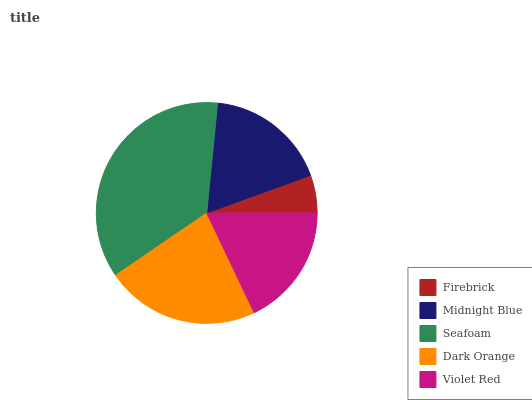Is Firebrick the minimum?
Answer yes or no. Yes. Is Seafoam the maximum?
Answer yes or no. Yes. Is Midnight Blue the minimum?
Answer yes or no. No. Is Midnight Blue the maximum?
Answer yes or no. No. Is Midnight Blue greater than Firebrick?
Answer yes or no. Yes. Is Firebrick less than Midnight Blue?
Answer yes or no. Yes. Is Firebrick greater than Midnight Blue?
Answer yes or no. No. Is Midnight Blue less than Firebrick?
Answer yes or no. No. Is Violet Red the high median?
Answer yes or no. Yes. Is Violet Red the low median?
Answer yes or no. Yes. Is Firebrick the high median?
Answer yes or no. No. Is Midnight Blue the low median?
Answer yes or no. No. 